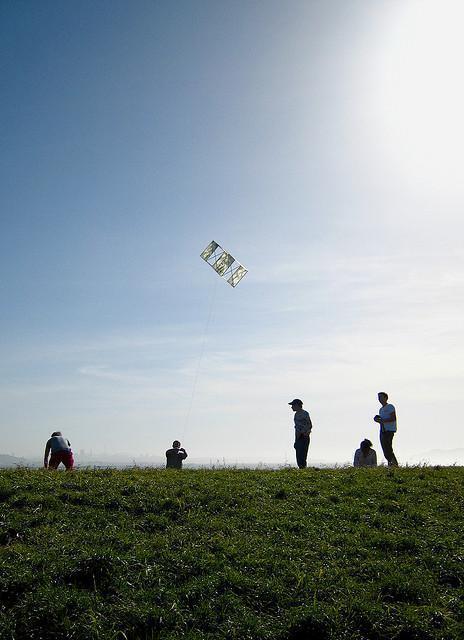How many bottles are in the picture?
Give a very brief answer. 0. 